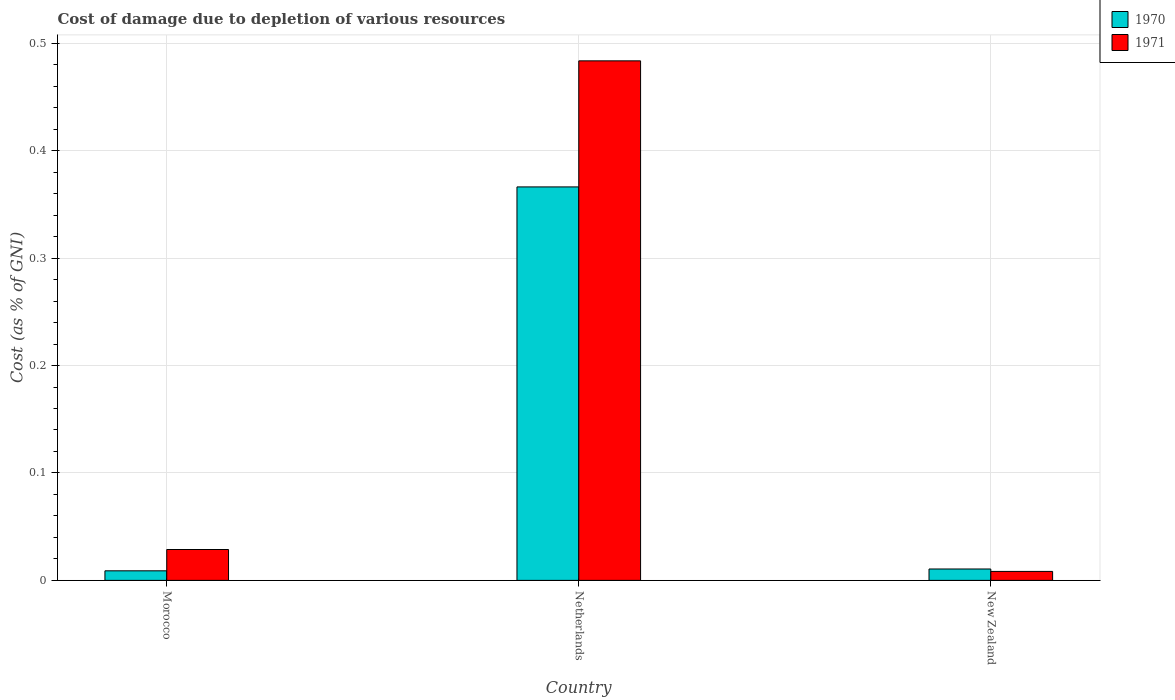Are the number of bars per tick equal to the number of legend labels?
Your response must be concise. Yes. Are the number of bars on each tick of the X-axis equal?
Your answer should be compact. Yes. How many bars are there on the 1st tick from the left?
Give a very brief answer. 2. How many bars are there on the 3rd tick from the right?
Your answer should be compact. 2. In how many cases, is the number of bars for a given country not equal to the number of legend labels?
Offer a very short reply. 0. What is the cost of damage caused due to the depletion of various resources in 1970 in New Zealand?
Your response must be concise. 0.01. Across all countries, what is the maximum cost of damage caused due to the depletion of various resources in 1970?
Ensure brevity in your answer.  0.37. Across all countries, what is the minimum cost of damage caused due to the depletion of various resources in 1971?
Provide a succinct answer. 0.01. In which country was the cost of damage caused due to the depletion of various resources in 1971 maximum?
Your answer should be compact. Netherlands. In which country was the cost of damage caused due to the depletion of various resources in 1970 minimum?
Provide a succinct answer. Morocco. What is the total cost of damage caused due to the depletion of various resources in 1971 in the graph?
Provide a succinct answer. 0.52. What is the difference between the cost of damage caused due to the depletion of various resources in 1971 in Morocco and that in New Zealand?
Give a very brief answer. 0.02. What is the difference between the cost of damage caused due to the depletion of various resources in 1971 in Morocco and the cost of damage caused due to the depletion of various resources in 1970 in Netherlands?
Provide a short and direct response. -0.34. What is the average cost of damage caused due to the depletion of various resources in 1971 per country?
Your answer should be compact. 0.17. What is the difference between the cost of damage caused due to the depletion of various resources of/in 1971 and cost of damage caused due to the depletion of various resources of/in 1970 in Morocco?
Your answer should be compact. 0.02. In how many countries, is the cost of damage caused due to the depletion of various resources in 1971 greater than 0.26 %?
Keep it short and to the point. 1. What is the ratio of the cost of damage caused due to the depletion of various resources in 1971 in Morocco to that in Netherlands?
Your response must be concise. 0.06. Is the cost of damage caused due to the depletion of various resources in 1971 in Morocco less than that in New Zealand?
Offer a terse response. No. What is the difference between the highest and the second highest cost of damage caused due to the depletion of various resources in 1970?
Offer a terse response. 0.36. What is the difference between the highest and the lowest cost of damage caused due to the depletion of various resources in 1971?
Keep it short and to the point. 0.48. In how many countries, is the cost of damage caused due to the depletion of various resources in 1971 greater than the average cost of damage caused due to the depletion of various resources in 1971 taken over all countries?
Provide a short and direct response. 1. Is the sum of the cost of damage caused due to the depletion of various resources in 1971 in Morocco and New Zealand greater than the maximum cost of damage caused due to the depletion of various resources in 1970 across all countries?
Your response must be concise. No. What does the 1st bar from the left in New Zealand represents?
Ensure brevity in your answer.  1970. Are all the bars in the graph horizontal?
Provide a succinct answer. No. How many countries are there in the graph?
Offer a terse response. 3. What is the difference between two consecutive major ticks on the Y-axis?
Your answer should be very brief. 0.1. Does the graph contain any zero values?
Make the answer very short. No. Where does the legend appear in the graph?
Give a very brief answer. Top right. How many legend labels are there?
Make the answer very short. 2. What is the title of the graph?
Offer a terse response. Cost of damage due to depletion of various resources. Does "2005" appear as one of the legend labels in the graph?
Your answer should be compact. No. What is the label or title of the X-axis?
Offer a terse response. Country. What is the label or title of the Y-axis?
Keep it short and to the point. Cost (as % of GNI). What is the Cost (as % of GNI) in 1970 in Morocco?
Keep it short and to the point. 0.01. What is the Cost (as % of GNI) in 1971 in Morocco?
Give a very brief answer. 0.03. What is the Cost (as % of GNI) of 1970 in Netherlands?
Provide a short and direct response. 0.37. What is the Cost (as % of GNI) of 1971 in Netherlands?
Offer a very short reply. 0.48. What is the Cost (as % of GNI) of 1970 in New Zealand?
Provide a succinct answer. 0.01. What is the Cost (as % of GNI) of 1971 in New Zealand?
Keep it short and to the point. 0.01. Across all countries, what is the maximum Cost (as % of GNI) of 1970?
Provide a short and direct response. 0.37. Across all countries, what is the maximum Cost (as % of GNI) in 1971?
Provide a short and direct response. 0.48. Across all countries, what is the minimum Cost (as % of GNI) of 1970?
Your response must be concise. 0.01. Across all countries, what is the minimum Cost (as % of GNI) in 1971?
Ensure brevity in your answer.  0.01. What is the total Cost (as % of GNI) of 1970 in the graph?
Provide a short and direct response. 0.39. What is the total Cost (as % of GNI) of 1971 in the graph?
Your response must be concise. 0.52. What is the difference between the Cost (as % of GNI) in 1970 in Morocco and that in Netherlands?
Your response must be concise. -0.36. What is the difference between the Cost (as % of GNI) of 1971 in Morocco and that in Netherlands?
Your answer should be very brief. -0.45. What is the difference between the Cost (as % of GNI) in 1970 in Morocco and that in New Zealand?
Provide a succinct answer. -0. What is the difference between the Cost (as % of GNI) of 1971 in Morocco and that in New Zealand?
Give a very brief answer. 0.02. What is the difference between the Cost (as % of GNI) of 1970 in Netherlands and that in New Zealand?
Your response must be concise. 0.36. What is the difference between the Cost (as % of GNI) of 1971 in Netherlands and that in New Zealand?
Provide a succinct answer. 0.48. What is the difference between the Cost (as % of GNI) of 1970 in Morocco and the Cost (as % of GNI) of 1971 in Netherlands?
Your response must be concise. -0.47. What is the difference between the Cost (as % of GNI) of 1970 in Morocco and the Cost (as % of GNI) of 1971 in New Zealand?
Offer a very short reply. 0. What is the difference between the Cost (as % of GNI) in 1970 in Netherlands and the Cost (as % of GNI) in 1971 in New Zealand?
Provide a succinct answer. 0.36. What is the average Cost (as % of GNI) of 1970 per country?
Provide a short and direct response. 0.13. What is the average Cost (as % of GNI) in 1971 per country?
Provide a short and direct response. 0.17. What is the difference between the Cost (as % of GNI) in 1970 and Cost (as % of GNI) in 1971 in Morocco?
Provide a succinct answer. -0.02. What is the difference between the Cost (as % of GNI) of 1970 and Cost (as % of GNI) of 1971 in Netherlands?
Your response must be concise. -0.12. What is the difference between the Cost (as % of GNI) of 1970 and Cost (as % of GNI) of 1971 in New Zealand?
Keep it short and to the point. 0. What is the ratio of the Cost (as % of GNI) of 1970 in Morocco to that in Netherlands?
Offer a very short reply. 0.02. What is the ratio of the Cost (as % of GNI) of 1971 in Morocco to that in Netherlands?
Offer a terse response. 0.06. What is the ratio of the Cost (as % of GNI) of 1970 in Morocco to that in New Zealand?
Provide a succinct answer. 0.84. What is the ratio of the Cost (as % of GNI) in 1971 in Morocco to that in New Zealand?
Make the answer very short. 3.44. What is the ratio of the Cost (as % of GNI) of 1970 in Netherlands to that in New Zealand?
Give a very brief answer. 34.53. What is the ratio of the Cost (as % of GNI) in 1971 in Netherlands to that in New Zealand?
Give a very brief answer. 57.9. What is the difference between the highest and the second highest Cost (as % of GNI) of 1970?
Keep it short and to the point. 0.36. What is the difference between the highest and the second highest Cost (as % of GNI) in 1971?
Your answer should be compact. 0.45. What is the difference between the highest and the lowest Cost (as % of GNI) in 1970?
Offer a terse response. 0.36. What is the difference between the highest and the lowest Cost (as % of GNI) in 1971?
Give a very brief answer. 0.48. 